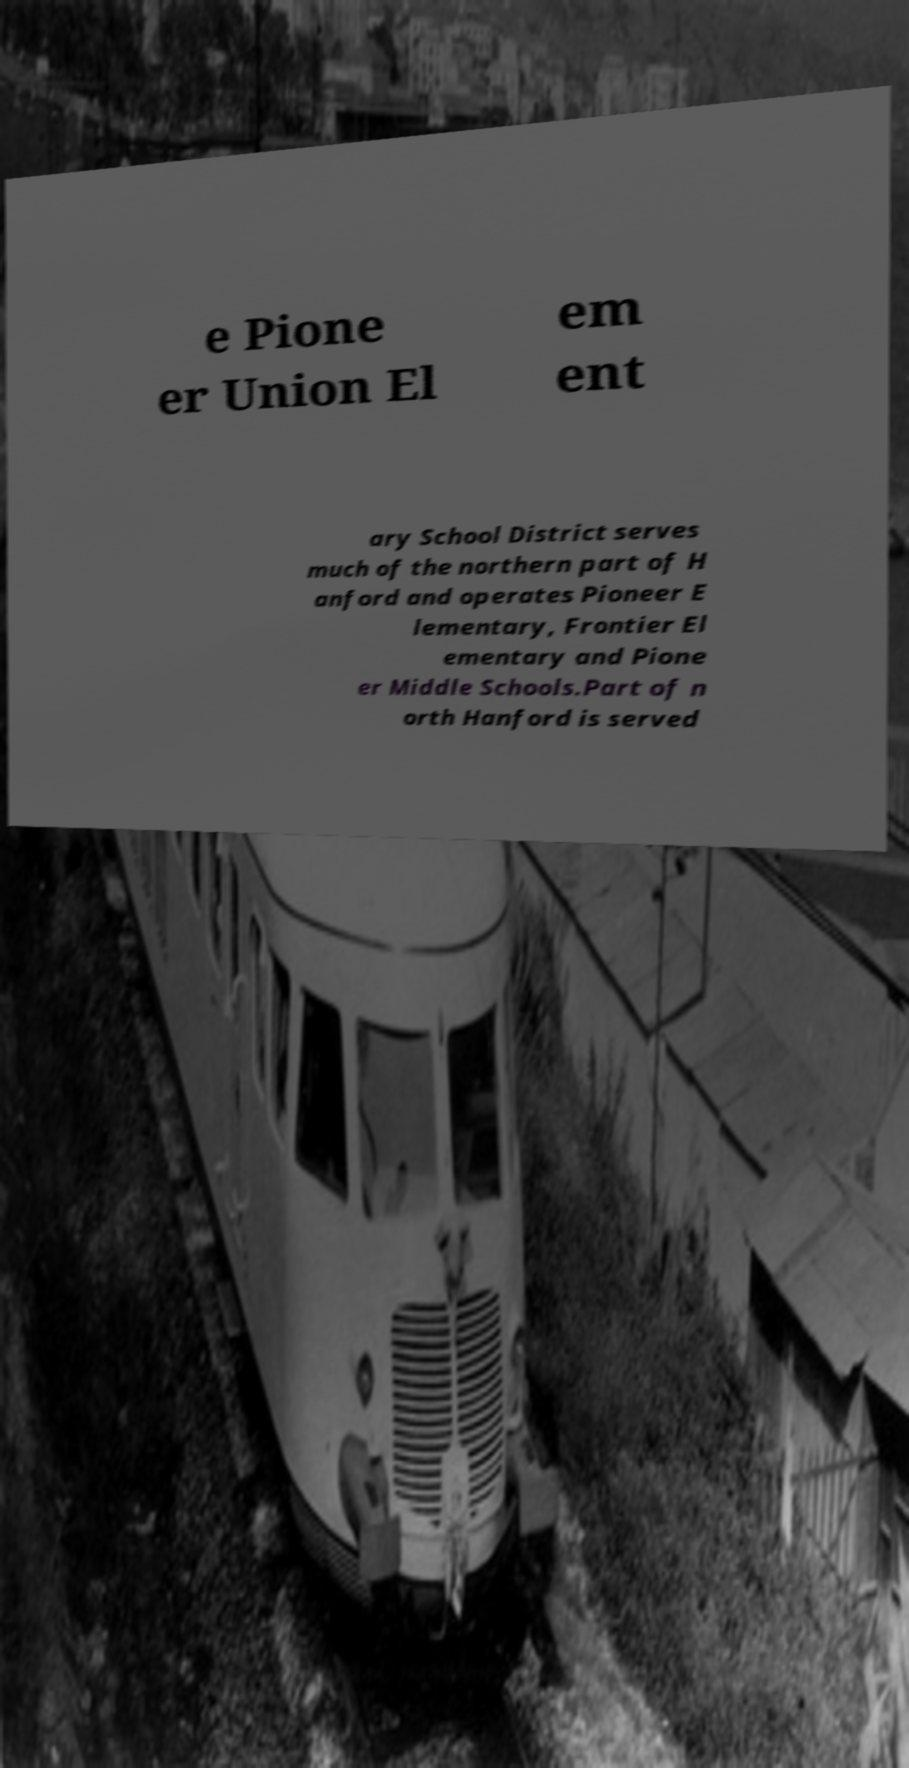Can you accurately transcribe the text from the provided image for me? e Pione er Union El em ent ary School District serves much of the northern part of H anford and operates Pioneer E lementary, Frontier El ementary and Pione er Middle Schools.Part of n orth Hanford is served 